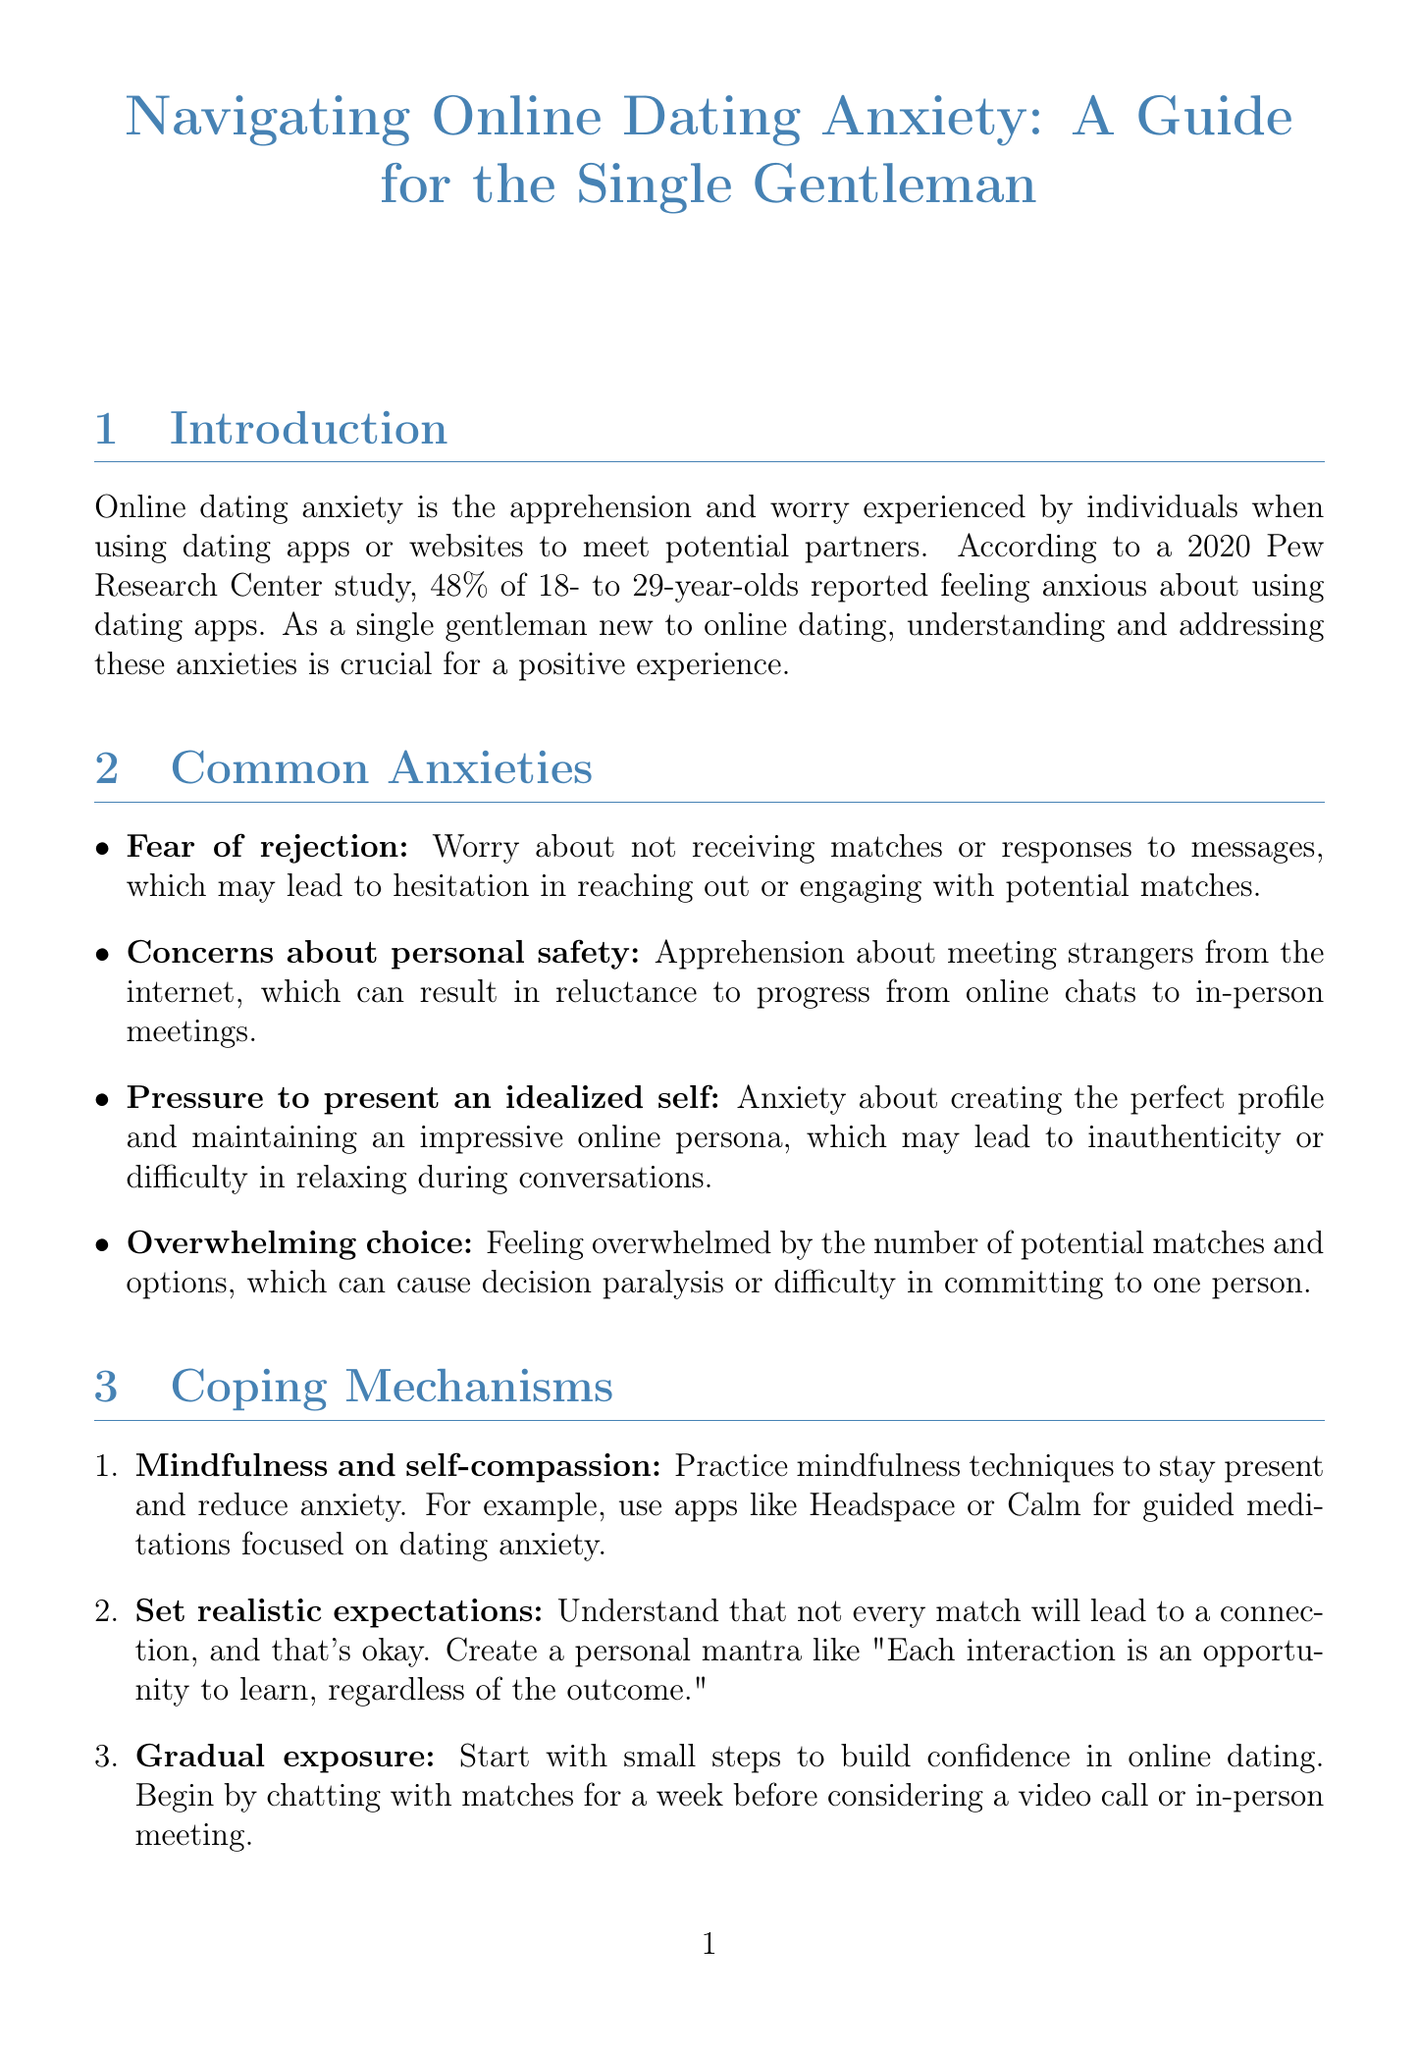What percentage of 18 to 29-year-olds reported feeling anxious about using dating apps? The document cites a 2020 Pew Research Center study showing that 48% of 18 to 29-year-olds reported feeling anxious.
Answer: 48% What is the name of the licensed clinical psychologist mentioned in the report? Dr. Sarah Thompson is identified as the licensed clinical psychologist specializing in relationship anxiety.
Answer: Dr. Sarah Thompson What is a practical example of mindfulness mentioned in the coping mechanisms? The document suggests using apps like Headspace or Calm for guided meditations focused on dating anxiety.
Answer: Headspace or Calm Which dating app feature reduces pressure on men to initiate conversations? The document states that Bumble allows women to message first, alleviating the anxiety of making the first move for men.
Answer: Women message first How long did John take to meet his current partner through online dating? John was able to meet his partner after three months of online dating as discussed in the success stories.
Answer: Three months What should one avoid doing too quickly according to online precautions? The report advises against sharing personal information too quickly on dating platforms.
Answer: Personal information What is one suggested environment for a first meeting according to safety measures? The document recommends choosing public locations for first meetings, such as popular coffee shops.
Answer: Popular coffee shops Who developed meaningful connections using therapy and mindfulness? The success story mentions Michael, who used therapy and mindfulness to improve his self-confidence and connections.
Answer: Michael 